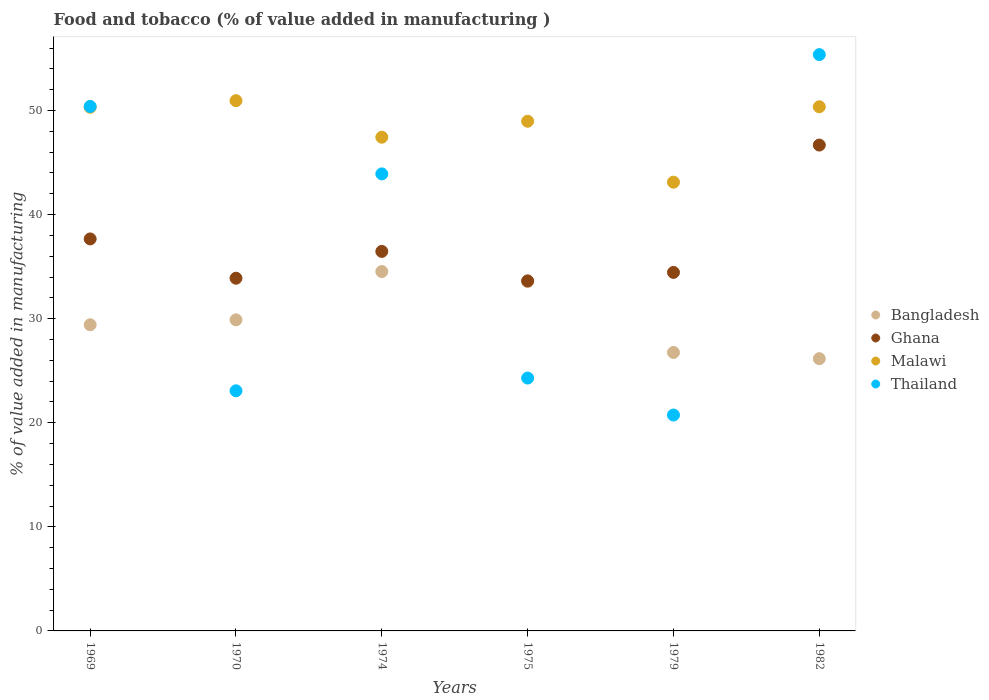How many different coloured dotlines are there?
Offer a very short reply. 4. Is the number of dotlines equal to the number of legend labels?
Ensure brevity in your answer.  Yes. What is the value added in manufacturing food and tobacco in Bangladesh in 1979?
Your answer should be very brief. 26.75. Across all years, what is the maximum value added in manufacturing food and tobacco in Ghana?
Your answer should be very brief. 46.68. Across all years, what is the minimum value added in manufacturing food and tobacco in Ghana?
Your answer should be compact. 33.63. In which year was the value added in manufacturing food and tobacco in Thailand maximum?
Make the answer very short. 1982. In which year was the value added in manufacturing food and tobacco in Malawi minimum?
Your answer should be very brief. 1979. What is the total value added in manufacturing food and tobacco in Thailand in the graph?
Keep it short and to the point. 217.79. What is the difference between the value added in manufacturing food and tobacco in Thailand in 1970 and that in 1974?
Your answer should be very brief. -20.84. What is the difference between the value added in manufacturing food and tobacco in Malawi in 1979 and the value added in manufacturing food and tobacco in Bangladesh in 1974?
Keep it short and to the point. 8.59. What is the average value added in manufacturing food and tobacco in Bangladesh per year?
Give a very brief answer. 30.05. In the year 1975, what is the difference between the value added in manufacturing food and tobacco in Bangladesh and value added in manufacturing food and tobacco in Thailand?
Make the answer very short. 9.27. In how many years, is the value added in manufacturing food and tobacco in Ghana greater than 20 %?
Make the answer very short. 6. What is the ratio of the value added in manufacturing food and tobacco in Bangladesh in 1974 to that in 1982?
Offer a terse response. 1.32. Is the value added in manufacturing food and tobacco in Thailand in 1979 less than that in 1982?
Provide a succinct answer. Yes. Is the difference between the value added in manufacturing food and tobacco in Bangladesh in 1979 and 1982 greater than the difference between the value added in manufacturing food and tobacco in Thailand in 1979 and 1982?
Your response must be concise. Yes. What is the difference between the highest and the second highest value added in manufacturing food and tobacco in Malawi?
Offer a very short reply. 0.58. What is the difference between the highest and the lowest value added in manufacturing food and tobacco in Ghana?
Your answer should be compact. 13.05. Is the sum of the value added in manufacturing food and tobacco in Malawi in 1975 and 1982 greater than the maximum value added in manufacturing food and tobacco in Thailand across all years?
Give a very brief answer. Yes. Is it the case that in every year, the sum of the value added in manufacturing food and tobacco in Thailand and value added in manufacturing food and tobacco in Malawi  is greater than the sum of value added in manufacturing food and tobacco in Ghana and value added in manufacturing food and tobacco in Bangladesh?
Offer a terse response. No. Is the value added in manufacturing food and tobacco in Bangladesh strictly greater than the value added in manufacturing food and tobacco in Thailand over the years?
Offer a terse response. No. Is the value added in manufacturing food and tobacco in Thailand strictly less than the value added in manufacturing food and tobacco in Ghana over the years?
Offer a terse response. No. How many dotlines are there?
Offer a terse response. 4. Does the graph contain grids?
Your response must be concise. No. How are the legend labels stacked?
Make the answer very short. Vertical. What is the title of the graph?
Offer a terse response. Food and tobacco (% of value added in manufacturing ). What is the label or title of the X-axis?
Provide a short and direct response. Years. What is the label or title of the Y-axis?
Your answer should be very brief. % of value added in manufacturing. What is the % of value added in manufacturing in Bangladesh in 1969?
Provide a short and direct response. 29.42. What is the % of value added in manufacturing of Ghana in 1969?
Your response must be concise. 37.66. What is the % of value added in manufacturing of Malawi in 1969?
Your answer should be very brief. 50.32. What is the % of value added in manufacturing of Thailand in 1969?
Your response must be concise. 50.39. What is the % of value added in manufacturing in Bangladesh in 1970?
Provide a short and direct response. 29.89. What is the % of value added in manufacturing of Ghana in 1970?
Make the answer very short. 33.89. What is the % of value added in manufacturing in Malawi in 1970?
Keep it short and to the point. 50.95. What is the % of value added in manufacturing in Thailand in 1970?
Your answer should be compact. 23.07. What is the % of value added in manufacturing in Bangladesh in 1974?
Make the answer very short. 34.53. What is the % of value added in manufacturing in Ghana in 1974?
Ensure brevity in your answer.  36.46. What is the % of value added in manufacturing of Malawi in 1974?
Give a very brief answer. 47.44. What is the % of value added in manufacturing in Thailand in 1974?
Offer a very short reply. 43.91. What is the % of value added in manufacturing in Bangladesh in 1975?
Offer a terse response. 33.56. What is the % of value added in manufacturing of Ghana in 1975?
Offer a terse response. 33.63. What is the % of value added in manufacturing of Malawi in 1975?
Provide a short and direct response. 48.97. What is the % of value added in manufacturing of Thailand in 1975?
Ensure brevity in your answer.  24.3. What is the % of value added in manufacturing in Bangladesh in 1979?
Make the answer very short. 26.75. What is the % of value added in manufacturing in Ghana in 1979?
Offer a terse response. 34.45. What is the % of value added in manufacturing in Malawi in 1979?
Offer a terse response. 43.12. What is the % of value added in manufacturing in Thailand in 1979?
Give a very brief answer. 20.74. What is the % of value added in manufacturing of Bangladesh in 1982?
Give a very brief answer. 26.16. What is the % of value added in manufacturing of Ghana in 1982?
Provide a short and direct response. 46.68. What is the % of value added in manufacturing of Malawi in 1982?
Provide a short and direct response. 50.36. What is the % of value added in manufacturing of Thailand in 1982?
Offer a very short reply. 55.37. Across all years, what is the maximum % of value added in manufacturing of Bangladesh?
Make the answer very short. 34.53. Across all years, what is the maximum % of value added in manufacturing in Ghana?
Make the answer very short. 46.68. Across all years, what is the maximum % of value added in manufacturing in Malawi?
Ensure brevity in your answer.  50.95. Across all years, what is the maximum % of value added in manufacturing in Thailand?
Make the answer very short. 55.37. Across all years, what is the minimum % of value added in manufacturing in Bangladesh?
Your answer should be very brief. 26.16. Across all years, what is the minimum % of value added in manufacturing in Ghana?
Keep it short and to the point. 33.63. Across all years, what is the minimum % of value added in manufacturing in Malawi?
Offer a terse response. 43.12. Across all years, what is the minimum % of value added in manufacturing in Thailand?
Make the answer very short. 20.74. What is the total % of value added in manufacturing in Bangladesh in the graph?
Give a very brief answer. 180.31. What is the total % of value added in manufacturing of Ghana in the graph?
Keep it short and to the point. 222.78. What is the total % of value added in manufacturing of Malawi in the graph?
Ensure brevity in your answer.  291.15. What is the total % of value added in manufacturing of Thailand in the graph?
Offer a very short reply. 217.79. What is the difference between the % of value added in manufacturing in Bangladesh in 1969 and that in 1970?
Your answer should be very brief. -0.47. What is the difference between the % of value added in manufacturing in Ghana in 1969 and that in 1970?
Your answer should be very brief. 3.77. What is the difference between the % of value added in manufacturing of Malawi in 1969 and that in 1970?
Your answer should be very brief. -0.63. What is the difference between the % of value added in manufacturing in Thailand in 1969 and that in 1970?
Provide a short and direct response. 27.32. What is the difference between the % of value added in manufacturing in Bangladesh in 1969 and that in 1974?
Your response must be concise. -5.11. What is the difference between the % of value added in manufacturing of Ghana in 1969 and that in 1974?
Your answer should be very brief. 1.2. What is the difference between the % of value added in manufacturing of Malawi in 1969 and that in 1974?
Provide a succinct answer. 2.88. What is the difference between the % of value added in manufacturing of Thailand in 1969 and that in 1974?
Offer a terse response. 6.48. What is the difference between the % of value added in manufacturing in Bangladesh in 1969 and that in 1975?
Give a very brief answer. -4.15. What is the difference between the % of value added in manufacturing in Ghana in 1969 and that in 1975?
Offer a very short reply. 4.03. What is the difference between the % of value added in manufacturing in Malawi in 1969 and that in 1975?
Provide a succinct answer. 1.35. What is the difference between the % of value added in manufacturing of Thailand in 1969 and that in 1975?
Provide a short and direct response. 26.1. What is the difference between the % of value added in manufacturing in Bangladesh in 1969 and that in 1979?
Make the answer very short. 2.66. What is the difference between the % of value added in manufacturing of Ghana in 1969 and that in 1979?
Keep it short and to the point. 3.22. What is the difference between the % of value added in manufacturing in Malawi in 1969 and that in 1979?
Offer a very short reply. 7.2. What is the difference between the % of value added in manufacturing of Thailand in 1969 and that in 1979?
Ensure brevity in your answer.  29.65. What is the difference between the % of value added in manufacturing in Bangladesh in 1969 and that in 1982?
Make the answer very short. 3.26. What is the difference between the % of value added in manufacturing in Ghana in 1969 and that in 1982?
Ensure brevity in your answer.  -9.02. What is the difference between the % of value added in manufacturing in Malawi in 1969 and that in 1982?
Provide a short and direct response. -0.05. What is the difference between the % of value added in manufacturing of Thailand in 1969 and that in 1982?
Your response must be concise. -4.98. What is the difference between the % of value added in manufacturing of Bangladesh in 1970 and that in 1974?
Make the answer very short. -4.64. What is the difference between the % of value added in manufacturing of Ghana in 1970 and that in 1974?
Your answer should be compact. -2.58. What is the difference between the % of value added in manufacturing in Malawi in 1970 and that in 1974?
Provide a short and direct response. 3.51. What is the difference between the % of value added in manufacturing of Thailand in 1970 and that in 1974?
Offer a terse response. -20.84. What is the difference between the % of value added in manufacturing in Bangladesh in 1970 and that in 1975?
Provide a short and direct response. -3.67. What is the difference between the % of value added in manufacturing of Ghana in 1970 and that in 1975?
Give a very brief answer. 0.26. What is the difference between the % of value added in manufacturing of Malawi in 1970 and that in 1975?
Give a very brief answer. 1.98. What is the difference between the % of value added in manufacturing of Thailand in 1970 and that in 1975?
Ensure brevity in your answer.  -1.23. What is the difference between the % of value added in manufacturing of Bangladesh in 1970 and that in 1979?
Provide a succinct answer. 3.14. What is the difference between the % of value added in manufacturing of Ghana in 1970 and that in 1979?
Ensure brevity in your answer.  -0.56. What is the difference between the % of value added in manufacturing of Malawi in 1970 and that in 1979?
Provide a short and direct response. 7.83. What is the difference between the % of value added in manufacturing of Thailand in 1970 and that in 1979?
Offer a very short reply. 2.33. What is the difference between the % of value added in manufacturing in Bangladesh in 1970 and that in 1982?
Provide a short and direct response. 3.73. What is the difference between the % of value added in manufacturing of Ghana in 1970 and that in 1982?
Keep it short and to the point. -12.79. What is the difference between the % of value added in manufacturing of Malawi in 1970 and that in 1982?
Make the answer very short. 0.58. What is the difference between the % of value added in manufacturing of Thailand in 1970 and that in 1982?
Your answer should be very brief. -32.3. What is the difference between the % of value added in manufacturing in Bangladesh in 1974 and that in 1975?
Your answer should be very brief. 0.97. What is the difference between the % of value added in manufacturing of Ghana in 1974 and that in 1975?
Make the answer very short. 2.83. What is the difference between the % of value added in manufacturing in Malawi in 1974 and that in 1975?
Your response must be concise. -1.53. What is the difference between the % of value added in manufacturing in Thailand in 1974 and that in 1975?
Keep it short and to the point. 19.62. What is the difference between the % of value added in manufacturing of Bangladesh in 1974 and that in 1979?
Your response must be concise. 7.78. What is the difference between the % of value added in manufacturing in Ghana in 1974 and that in 1979?
Provide a succinct answer. 2.02. What is the difference between the % of value added in manufacturing in Malawi in 1974 and that in 1979?
Ensure brevity in your answer.  4.32. What is the difference between the % of value added in manufacturing of Thailand in 1974 and that in 1979?
Offer a very short reply. 23.17. What is the difference between the % of value added in manufacturing of Bangladesh in 1974 and that in 1982?
Your answer should be very brief. 8.37. What is the difference between the % of value added in manufacturing of Ghana in 1974 and that in 1982?
Make the answer very short. -10.22. What is the difference between the % of value added in manufacturing in Malawi in 1974 and that in 1982?
Make the answer very short. -2.93. What is the difference between the % of value added in manufacturing of Thailand in 1974 and that in 1982?
Give a very brief answer. -11.46. What is the difference between the % of value added in manufacturing in Bangladesh in 1975 and that in 1979?
Your response must be concise. 6.81. What is the difference between the % of value added in manufacturing in Ghana in 1975 and that in 1979?
Your answer should be very brief. -0.81. What is the difference between the % of value added in manufacturing of Malawi in 1975 and that in 1979?
Your answer should be compact. 5.86. What is the difference between the % of value added in manufacturing in Thailand in 1975 and that in 1979?
Your response must be concise. 3.55. What is the difference between the % of value added in manufacturing of Bangladesh in 1975 and that in 1982?
Ensure brevity in your answer.  7.41. What is the difference between the % of value added in manufacturing in Ghana in 1975 and that in 1982?
Offer a terse response. -13.05. What is the difference between the % of value added in manufacturing of Malawi in 1975 and that in 1982?
Provide a short and direct response. -1.39. What is the difference between the % of value added in manufacturing in Thailand in 1975 and that in 1982?
Ensure brevity in your answer.  -31.08. What is the difference between the % of value added in manufacturing of Bangladesh in 1979 and that in 1982?
Offer a very short reply. 0.6. What is the difference between the % of value added in manufacturing of Ghana in 1979 and that in 1982?
Your answer should be compact. -12.24. What is the difference between the % of value added in manufacturing of Malawi in 1979 and that in 1982?
Your answer should be very brief. -7.25. What is the difference between the % of value added in manufacturing of Thailand in 1979 and that in 1982?
Make the answer very short. -34.63. What is the difference between the % of value added in manufacturing of Bangladesh in 1969 and the % of value added in manufacturing of Ghana in 1970?
Your response must be concise. -4.47. What is the difference between the % of value added in manufacturing in Bangladesh in 1969 and the % of value added in manufacturing in Malawi in 1970?
Offer a terse response. -21.53. What is the difference between the % of value added in manufacturing of Bangladesh in 1969 and the % of value added in manufacturing of Thailand in 1970?
Make the answer very short. 6.35. What is the difference between the % of value added in manufacturing of Ghana in 1969 and the % of value added in manufacturing of Malawi in 1970?
Offer a very short reply. -13.28. What is the difference between the % of value added in manufacturing of Ghana in 1969 and the % of value added in manufacturing of Thailand in 1970?
Offer a very short reply. 14.59. What is the difference between the % of value added in manufacturing in Malawi in 1969 and the % of value added in manufacturing in Thailand in 1970?
Provide a succinct answer. 27.25. What is the difference between the % of value added in manufacturing of Bangladesh in 1969 and the % of value added in manufacturing of Ghana in 1974?
Offer a very short reply. -7.05. What is the difference between the % of value added in manufacturing in Bangladesh in 1969 and the % of value added in manufacturing in Malawi in 1974?
Give a very brief answer. -18.02. What is the difference between the % of value added in manufacturing in Bangladesh in 1969 and the % of value added in manufacturing in Thailand in 1974?
Offer a very short reply. -14.49. What is the difference between the % of value added in manufacturing of Ghana in 1969 and the % of value added in manufacturing of Malawi in 1974?
Your answer should be compact. -9.77. What is the difference between the % of value added in manufacturing of Ghana in 1969 and the % of value added in manufacturing of Thailand in 1974?
Your answer should be compact. -6.25. What is the difference between the % of value added in manufacturing in Malawi in 1969 and the % of value added in manufacturing in Thailand in 1974?
Make the answer very short. 6.4. What is the difference between the % of value added in manufacturing of Bangladesh in 1969 and the % of value added in manufacturing of Ghana in 1975?
Give a very brief answer. -4.22. What is the difference between the % of value added in manufacturing in Bangladesh in 1969 and the % of value added in manufacturing in Malawi in 1975?
Your answer should be compact. -19.55. What is the difference between the % of value added in manufacturing in Bangladesh in 1969 and the % of value added in manufacturing in Thailand in 1975?
Your response must be concise. 5.12. What is the difference between the % of value added in manufacturing in Ghana in 1969 and the % of value added in manufacturing in Malawi in 1975?
Provide a short and direct response. -11.31. What is the difference between the % of value added in manufacturing in Ghana in 1969 and the % of value added in manufacturing in Thailand in 1975?
Provide a succinct answer. 13.37. What is the difference between the % of value added in manufacturing in Malawi in 1969 and the % of value added in manufacturing in Thailand in 1975?
Your response must be concise. 26.02. What is the difference between the % of value added in manufacturing of Bangladesh in 1969 and the % of value added in manufacturing of Ghana in 1979?
Provide a short and direct response. -5.03. What is the difference between the % of value added in manufacturing in Bangladesh in 1969 and the % of value added in manufacturing in Malawi in 1979?
Your answer should be very brief. -13.7. What is the difference between the % of value added in manufacturing of Bangladesh in 1969 and the % of value added in manufacturing of Thailand in 1979?
Your answer should be very brief. 8.67. What is the difference between the % of value added in manufacturing in Ghana in 1969 and the % of value added in manufacturing in Malawi in 1979?
Provide a short and direct response. -5.45. What is the difference between the % of value added in manufacturing in Ghana in 1969 and the % of value added in manufacturing in Thailand in 1979?
Make the answer very short. 16.92. What is the difference between the % of value added in manufacturing of Malawi in 1969 and the % of value added in manufacturing of Thailand in 1979?
Keep it short and to the point. 29.57. What is the difference between the % of value added in manufacturing in Bangladesh in 1969 and the % of value added in manufacturing in Ghana in 1982?
Offer a very short reply. -17.27. What is the difference between the % of value added in manufacturing of Bangladesh in 1969 and the % of value added in manufacturing of Malawi in 1982?
Provide a succinct answer. -20.95. What is the difference between the % of value added in manufacturing in Bangladesh in 1969 and the % of value added in manufacturing in Thailand in 1982?
Give a very brief answer. -25.96. What is the difference between the % of value added in manufacturing in Ghana in 1969 and the % of value added in manufacturing in Malawi in 1982?
Provide a short and direct response. -12.7. What is the difference between the % of value added in manufacturing of Ghana in 1969 and the % of value added in manufacturing of Thailand in 1982?
Your answer should be compact. -17.71. What is the difference between the % of value added in manufacturing in Malawi in 1969 and the % of value added in manufacturing in Thailand in 1982?
Your answer should be very brief. -5.06. What is the difference between the % of value added in manufacturing in Bangladesh in 1970 and the % of value added in manufacturing in Ghana in 1974?
Your answer should be compact. -6.57. What is the difference between the % of value added in manufacturing of Bangladesh in 1970 and the % of value added in manufacturing of Malawi in 1974?
Offer a very short reply. -17.54. What is the difference between the % of value added in manufacturing in Bangladesh in 1970 and the % of value added in manufacturing in Thailand in 1974?
Your answer should be compact. -14.02. What is the difference between the % of value added in manufacturing in Ghana in 1970 and the % of value added in manufacturing in Malawi in 1974?
Ensure brevity in your answer.  -13.55. What is the difference between the % of value added in manufacturing of Ghana in 1970 and the % of value added in manufacturing of Thailand in 1974?
Provide a succinct answer. -10.02. What is the difference between the % of value added in manufacturing of Malawi in 1970 and the % of value added in manufacturing of Thailand in 1974?
Give a very brief answer. 7.04. What is the difference between the % of value added in manufacturing of Bangladesh in 1970 and the % of value added in manufacturing of Ghana in 1975?
Your answer should be very brief. -3.74. What is the difference between the % of value added in manufacturing of Bangladesh in 1970 and the % of value added in manufacturing of Malawi in 1975?
Provide a short and direct response. -19.08. What is the difference between the % of value added in manufacturing of Bangladesh in 1970 and the % of value added in manufacturing of Thailand in 1975?
Your response must be concise. 5.6. What is the difference between the % of value added in manufacturing of Ghana in 1970 and the % of value added in manufacturing of Malawi in 1975?
Your answer should be compact. -15.08. What is the difference between the % of value added in manufacturing in Ghana in 1970 and the % of value added in manufacturing in Thailand in 1975?
Your answer should be very brief. 9.59. What is the difference between the % of value added in manufacturing of Malawi in 1970 and the % of value added in manufacturing of Thailand in 1975?
Ensure brevity in your answer.  26.65. What is the difference between the % of value added in manufacturing in Bangladesh in 1970 and the % of value added in manufacturing in Ghana in 1979?
Offer a terse response. -4.56. What is the difference between the % of value added in manufacturing of Bangladesh in 1970 and the % of value added in manufacturing of Malawi in 1979?
Keep it short and to the point. -13.22. What is the difference between the % of value added in manufacturing in Bangladesh in 1970 and the % of value added in manufacturing in Thailand in 1979?
Your answer should be very brief. 9.15. What is the difference between the % of value added in manufacturing of Ghana in 1970 and the % of value added in manufacturing of Malawi in 1979?
Offer a terse response. -9.23. What is the difference between the % of value added in manufacturing in Ghana in 1970 and the % of value added in manufacturing in Thailand in 1979?
Give a very brief answer. 13.14. What is the difference between the % of value added in manufacturing in Malawi in 1970 and the % of value added in manufacturing in Thailand in 1979?
Provide a succinct answer. 30.2. What is the difference between the % of value added in manufacturing of Bangladesh in 1970 and the % of value added in manufacturing of Ghana in 1982?
Provide a succinct answer. -16.79. What is the difference between the % of value added in manufacturing in Bangladesh in 1970 and the % of value added in manufacturing in Malawi in 1982?
Ensure brevity in your answer.  -20.47. What is the difference between the % of value added in manufacturing of Bangladesh in 1970 and the % of value added in manufacturing of Thailand in 1982?
Your answer should be very brief. -25.48. What is the difference between the % of value added in manufacturing of Ghana in 1970 and the % of value added in manufacturing of Malawi in 1982?
Offer a very short reply. -16.47. What is the difference between the % of value added in manufacturing in Ghana in 1970 and the % of value added in manufacturing in Thailand in 1982?
Your response must be concise. -21.49. What is the difference between the % of value added in manufacturing in Malawi in 1970 and the % of value added in manufacturing in Thailand in 1982?
Provide a short and direct response. -4.43. What is the difference between the % of value added in manufacturing of Bangladesh in 1974 and the % of value added in manufacturing of Ghana in 1975?
Provide a short and direct response. 0.9. What is the difference between the % of value added in manufacturing of Bangladesh in 1974 and the % of value added in manufacturing of Malawi in 1975?
Keep it short and to the point. -14.44. What is the difference between the % of value added in manufacturing in Bangladesh in 1974 and the % of value added in manufacturing in Thailand in 1975?
Your answer should be compact. 10.23. What is the difference between the % of value added in manufacturing in Ghana in 1974 and the % of value added in manufacturing in Malawi in 1975?
Your answer should be very brief. -12.51. What is the difference between the % of value added in manufacturing in Ghana in 1974 and the % of value added in manufacturing in Thailand in 1975?
Your response must be concise. 12.17. What is the difference between the % of value added in manufacturing of Malawi in 1974 and the % of value added in manufacturing of Thailand in 1975?
Ensure brevity in your answer.  23.14. What is the difference between the % of value added in manufacturing of Bangladesh in 1974 and the % of value added in manufacturing of Ghana in 1979?
Your answer should be very brief. 0.08. What is the difference between the % of value added in manufacturing in Bangladesh in 1974 and the % of value added in manufacturing in Malawi in 1979?
Offer a terse response. -8.59. What is the difference between the % of value added in manufacturing of Bangladesh in 1974 and the % of value added in manufacturing of Thailand in 1979?
Your answer should be compact. 13.79. What is the difference between the % of value added in manufacturing of Ghana in 1974 and the % of value added in manufacturing of Malawi in 1979?
Offer a very short reply. -6.65. What is the difference between the % of value added in manufacturing of Ghana in 1974 and the % of value added in manufacturing of Thailand in 1979?
Ensure brevity in your answer.  15.72. What is the difference between the % of value added in manufacturing in Malawi in 1974 and the % of value added in manufacturing in Thailand in 1979?
Your answer should be very brief. 26.69. What is the difference between the % of value added in manufacturing in Bangladesh in 1974 and the % of value added in manufacturing in Ghana in 1982?
Provide a short and direct response. -12.15. What is the difference between the % of value added in manufacturing of Bangladesh in 1974 and the % of value added in manufacturing of Malawi in 1982?
Provide a succinct answer. -15.83. What is the difference between the % of value added in manufacturing in Bangladesh in 1974 and the % of value added in manufacturing in Thailand in 1982?
Make the answer very short. -20.84. What is the difference between the % of value added in manufacturing in Ghana in 1974 and the % of value added in manufacturing in Malawi in 1982?
Provide a succinct answer. -13.9. What is the difference between the % of value added in manufacturing of Ghana in 1974 and the % of value added in manufacturing of Thailand in 1982?
Your answer should be compact. -18.91. What is the difference between the % of value added in manufacturing of Malawi in 1974 and the % of value added in manufacturing of Thailand in 1982?
Offer a terse response. -7.94. What is the difference between the % of value added in manufacturing in Bangladesh in 1975 and the % of value added in manufacturing in Ghana in 1979?
Offer a terse response. -0.88. What is the difference between the % of value added in manufacturing in Bangladesh in 1975 and the % of value added in manufacturing in Malawi in 1979?
Provide a succinct answer. -9.55. What is the difference between the % of value added in manufacturing in Bangladesh in 1975 and the % of value added in manufacturing in Thailand in 1979?
Provide a short and direct response. 12.82. What is the difference between the % of value added in manufacturing in Ghana in 1975 and the % of value added in manufacturing in Malawi in 1979?
Make the answer very short. -9.48. What is the difference between the % of value added in manufacturing in Ghana in 1975 and the % of value added in manufacturing in Thailand in 1979?
Your answer should be compact. 12.89. What is the difference between the % of value added in manufacturing of Malawi in 1975 and the % of value added in manufacturing of Thailand in 1979?
Provide a succinct answer. 28.23. What is the difference between the % of value added in manufacturing of Bangladesh in 1975 and the % of value added in manufacturing of Ghana in 1982?
Make the answer very short. -13.12. What is the difference between the % of value added in manufacturing of Bangladesh in 1975 and the % of value added in manufacturing of Malawi in 1982?
Provide a short and direct response. -16.8. What is the difference between the % of value added in manufacturing in Bangladesh in 1975 and the % of value added in manufacturing in Thailand in 1982?
Offer a very short reply. -21.81. What is the difference between the % of value added in manufacturing of Ghana in 1975 and the % of value added in manufacturing of Malawi in 1982?
Give a very brief answer. -16.73. What is the difference between the % of value added in manufacturing of Ghana in 1975 and the % of value added in manufacturing of Thailand in 1982?
Ensure brevity in your answer.  -21.74. What is the difference between the % of value added in manufacturing of Malawi in 1975 and the % of value added in manufacturing of Thailand in 1982?
Offer a very short reply. -6.4. What is the difference between the % of value added in manufacturing of Bangladesh in 1979 and the % of value added in manufacturing of Ghana in 1982?
Give a very brief answer. -19.93. What is the difference between the % of value added in manufacturing of Bangladesh in 1979 and the % of value added in manufacturing of Malawi in 1982?
Offer a very short reply. -23.61. What is the difference between the % of value added in manufacturing of Bangladesh in 1979 and the % of value added in manufacturing of Thailand in 1982?
Keep it short and to the point. -28.62. What is the difference between the % of value added in manufacturing of Ghana in 1979 and the % of value added in manufacturing of Malawi in 1982?
Provide a succinct answer. -15.92. What is the difference between the % of value added in manufacturing of Ghana in 1979 and the % of value added in manufacturing of Thailand in 1982?
Your response must be concise. -20.93. What is the difference between the % of value added in manufacturing in Malawi in 1979 and the % of value added in manufacturing in Thailand in 1982?
Ensure brevity in your answer.  -12.26. What is the average % of value added in manufacturing in Bangladesh per year?
Offer a terse response. 30.05. What is the average % of value added in manufacturing of Ghana per year?
Provide a short and direct response. 37.13. What is the average % of value added in manufacturing in Malawi per year?
Your response must be concise. 48.52. What is the average % of value added in manufacturing of Thailand per year?
Your response must be concise. 36.3. In the year 1969, what is the difference between the % of value added in manufacturing in Bangladesh and % of value added in manufacturing in Ghana?
Offer a very short reply. -8.25. In the year 1969, what is the difference between the % of value added in manufacturing in Bangladesh and % of value added in manufacturing in Malawi?
Provide a succinct answer. -20.9. In the year 1969, what is the difference between the % of value added in manufacturing of Bangladesh and % of value added in manufacturing of Thailand?
Your answer should be very brief. -20.98. In the year 1969, what is the difference between the % of value added in manufacturing in Ghana and % of value added in manufacturing in Malawi?
Provide a short and direct response. -12.65. In the year 1969, what is the difference between the % of value added in manufacturing in Ghana and % of value added in manufacturing in Thailand?
Your response must be concise. -12.73. In the year 1969, what is the difference between the % of value added in manufacturing in Malawi and % of value added in manufacturing in Thailand?
Your answer should be compact. -0.08. In the year 1970, what is the difference between the % of value added in manufacturing in Bangladesh and % of value added in manufacturing in Ghana?
Offer a very short reply. -4. In the year 1970, what is the difference between the % of value added in manufacturing in Bangladesh and % of value added in manufacturing in Malawi?
Ensure brevity in your answer.  -21.06. In the year 1970, what is the difference between the % of value added in manufacturing in Bangladesh and % of value added in manufacturing in Thailand?
Offer a terse response. 6.82. In the year 1970, what is the difference between the % of value added in manufacturing of Ghana and % of value added in manufacturing of Malawi?
Give a very brief answer. -17.06. In the year 1970, what is the difference between the % of value added in manufacturing of Ghana and % of value added in manufacturing of Thailand?
Offer a very short reply. 10.82. In the year 1970, what is the difference between the % of value added in manufacturing of Malawi and % of value added in manufacturing of Thailand?
Your answer should be compact. 27.88. In the year 1974, what is the difference between the % of value added in manufacturing of Bangladesh and % of value added in manufacturing of Ghana?
Offer a very short reply. -1.93. In the year 1974, what is the difference between the % of value added in manufacturing of Bangladesh and % of value added in manufacturing of Malawi?
Provide a succinct answer. -12.91. In the year 1974, what is the difference between the % of value added in manufacturing of Bangladesh and % of value added in manufacturing of Thailand?
Your response must be concise. -9.38. In the year 1974, what is the difference between the % of value added in manufacturing of Ghana and % of value added in manufacturing of Malawi?
Your response must be concise. -10.97. In the year 1974, what is the difference between the % of value added in manufacturing of Ghana and % of value added in manufacturing of Thailand?
Your answer should be very brief. -7.45. In the year 1974, what is the difference between the % of value added in manufacturing of Malawi and % of value added in manufacturing of Thailand?
Ensure brevity in your answer.  3.52. In the year 1975, what is the difference between the % of value added in manufacturing in Bangladesh and % of value added in manufacturing in Ghana?
Your answer should be very brief. -0.07. In the year 1975, what is the difference between the % of value added in manufacturing of Bangladesh and % of value added in manufacturing of Malawi?
Make the answer very short. -15.41. In the year 1975, what is the difference between the % of value added in manufacturing in Bangladesh and % of value added in manufacturing in Thailand?
Ensure brevity in your answer.  9.27. In the year 1975, what is the difference between the % of value added in manufacturing of Ghana and % of value added in manufacturing of Malawi?
Give a very brief answer. -15.34. In the year 1975, what is the difference between the % of value added in manufacturing of Ghana and % of value added in manufacturing of Thailand?
Give a very brief answer. 9.34. In the year 1975, what is the difference between the % of value added in manufacturing in Malawi and % of value added in manufacturing in Thailand?
Ensure brevity in your answer.  24.68. In the year 1979, what is the difference between the % of value added in manufacturing in Bangladesh and % of value added in manufacturing in Ghana?
Provide a short and direct response. -7.69. In the year 1979, what is the difference between the % of value added in manufacturing of Bangladesh and % of value added in manufacturing of Malawi?
Offer a terse response. -16.36. In the year 1979, what is the difference between the % of value added in manufacturing in Bangladesh and % of value added in manufacturing in Thailand?
Your answer should be compact. 6.01. In the year 1979, what is the difference between the % of value added in manufacturing in Ghana and % of value added in manufacturing in Malawi?
Keep it short and to the point. -8.67. In the year 1979, what is the difference between the % of value added in manufacturing of Ghana and % of value added in manufacturing of Thailand?
Provide a short and direct response. 13.7. In the year 1979, what is the difference between the % of value added in manufacturing in Malawi and % of value added in manufacturing in Thailand?
Your answer should be compact. 22.37. In the year 1982, what is the difference between the % of value added in manufacturing in Bangladesh and % of value added in manufacturing in Ghana?
Your answer should be compact. -20.52. In the year 1982, what is the difference between the % of value added in manufacturing of Bangladesh and % of value added in manufacturing of Malawi?
Keep it short and to the point. -24.2. In the year 1982, what is the difference between the % of value added in manufacturing of Bangladesh and % of value added in manufacturing of Thailand?
Your answer should be compact. -29.22. In the year 1982, what is the difference between the % of value added in manufacturing in Ghana and % of value added in manufacturing in Malawi?
Ensure brevity in your answer.  -3.68. In the year 1982, what is the difference between the % of value added in manufacturing of Ghana and % of value added in manufacturing of Thailand?
Your answer should be compact. -8.69. In the year 1982, what is the difference between the % of value added in manufacturing of Malawi and % of value added in manufacturing of Thailand?
Your response must be concise. -5.01. What is the ratio of the % of value added in manufacturing of Bangladesh in 1969 to that in 1970?
Make the answer very short. 0.98. What is the ratio of the % of value added in manufacturing in Ghana in 1969 to that in 1970?
Give a very brief answer. 1.11. What is the ratio of the % of value added in manufacturing of Malawi in 1969 to that in 1970?
Give a very brief answer. 0.99. What is the ratio of the % of value added in manufacturing in Thailand in 1969 to that in 1970?
Offer a very short reply. 2.18. What is the ratio of the % of value added in manufacturing of Bangladesh in 1969 to that in 1974?
Your answer should be very brief. 0.85. What is the ratio of the % of value added in manufacturing of Ghana in 1969 to that in 1974?
Provide a succinct answer. 1.03. What is the ratio of the % of value added in manufacturing of Malawi in 1969 to that in 1974?
Provide a succinct answer. 1.06. What is the ratio of the % of value added in manufacturing of Thailand in 1969 to that in 1974?
Ensure brevity in your answer.  1.15. What is the ratio of the % of value added in manufacturing of Bangladesh in 1969 to that in 1975?
Offer a very short reply. 0.88. What is the ratio of the % of value added in manufacturing in Ghana in 1969 to that in 1975?
Provide a short and direct response. 1.12. What is the ratio of the % of value added in manufacturing in Malawi in 1969 to that in 1975?
Ensure brevity in your answer.  1.03. What is the ratio of the % of value added in manufacturing of Thailand in 1969 to that in 1975?
Give a very brief answer. 2.07. What is the ratio of the % of value added in manufacturing of Bangladesh in 1969 to that in 1979?
Provide a succinct answer. 1.1. What is the ratio of the % of value added in manufacturing of Ghana in 1969 to that in 1979?
Give a very brief answer. 1.09. What is the ratio of the % of value added in manufacturing of Malawi in 1969 to that in 1979?
Offer a very short reply. 1.17. What is the ratio of the % of value added in manufacturing in Thailand in 1969 to that in 1979?
Provide a succinct answer. 2.43. What is the ratio of the % of value added in manufacturing of Bangladesh in 1969 to that in 1982?
Your answer should be compact. 1.12. What is the ratio of the % of value added in manufacturing of Ghana in 1969 to that in 1982?
Ensure brevity in your answer.  0.81. What is the ratio of the % of value added in manufacturing in Malawi in 1969 to that in 1982?
Your answer should be compact. 1. What is the ratio of the % of value added in manufacturing of Thailand in 1969 to that in 1982?
Ensure brevity in your answer.  0.91. What is the ratio of the % of value added in manufacturing in Bangladesh in 1970 to that in 1974?
Offer a terse response. 0.87. What is the ratio of the % of value added in manufacturing of Ghana in 1970 to that in 1974?
Keep it short and to the point. 0.93. What is the ratio of the % of value added in manufacturing of Malawi in 1970 to that in 1974?
Your answer should be very brief. 1.07. What is the ratio of the % of value added in manufacturing in Thailand in 1970 to that in 1974?
Offer a terse response. 0.53. What is the ratio of the % of value added in manufacturing of Bangladesh in 1970 to that in 1975?
Ensure brevity in your answer.  0.89. What is the ratio of the % of value added in manufacturing of Ghana in 1970 to that in 1975?
Give a very brief answer. 1.01. What is the ratio of the % of value added in manufacturing of Malawi in 1970 to that in 1975?
Your response must be concise. 1.04. What is the ratio of the % of value added in manufacturing of Thailand in 1970 to that in 1975?
Provide a short and direct response. 0.95. What is the ratio of the % of value added in manufacturing in Bangladesh in 1970 to that in 1979?
Your answer should be compact. 1.12. What is the ratio of the % of value added in manufacturing of Ghana in 1970 to that in 1979?
Your response must be concise. 0.98. What is the ratio of the % of value added in manufacturing of Malawi in 1970 to that in 1979?
Your response must be concise. 1.18. What is the ratio of the % of value added in manufacturing of Thailand in 1970 to that in 1979?
Your answer should be compact. 1.11. What is the ratio of the % of value added in manufacturing of Bangladesh in 1970 to that in 1982?
Offer a terse response. 1.14. What is the ratio of the % of value added in manufacturing in Ghana in 1970 to that in 1982?
Your answer should be very brief. 0.73. What is the ratio of the % of value added in manufacturing in Malawi in 1970 to that in 1982?
Keep it short and to the point. 1.01. What is the ratio of the % of value added in manufacturing in Thailand in 1970 to that in 1982?
Offer a terse response. 0.42. What is the ratio of the % of value added in manufacturing in Bangladesh in 1974 to that in 1975?
Your answer should be very brief. 1.03. What is the ratio of the % of value added in manufacturing in Ghana in 1974 to that in 1975?
Give a very brief answer. 1.08. What is the ratio of the % of value added in manufacturing of Malawi in 1974 to that in 1975?
Ensure brevity in your answer.  0.97. What is the ratio of the % of value added in manufacturing of Thailand in 1974 to that in 1975?
Keep it short and to the point. 1.81. What is the ratio of the % of value added in manufacturing of Bangladesh in 1974 to that in 1979?
Provide a short and direct response. 1.29. What is the ratio of the % of value added in manufacturing of Ghana in 1974 to that in 1979?
Keep it short and to the point. 1.06. What is the ratio of the % of value added in manufacturing of Malawi in 1974 to that in 1979?
Offer a terse response. 1.1. What is the ratio of the % of value added in manufacturing of Thailand in 1974 to that in 1979?
Keep it short and to the point. 2.12. What is the ratio of the % of value added in manufacturing in Bangladesh in 1974 to that in 1982?
Your answer should be compact. 1.32. What is the ratio of the % of value added in manufacturing of Ghana in 1974 to that in 1982?
Ensure brevity in your answer.  0.78. What is the ratio of the % of value added in manufacturing of Malawi in 1974 to that in 1982?
Provide a short and direct response. 0.94. What is the ratio of the % of value added in manufacturing of Thailand in 1974 to that in 1982?
Make the answer very short. 0.79. What is the ratio of the % of value added in manufacturing of Bangladesh in 1975 to that in 1979?
Your answer should be very brief. 1.25. What is the ratio of the % of value added in manufacturing in Ghana in 1975 to that in 1979?
Offer a very short reply. 0.98. What is the ratio of the % of value added in manufacturing in Malawi in 1975 to that in 1979?
Offer a terse response. 1.14. What is the ratio of the % of value added in manufacturing of Thailand in 1975 to that in 1979?
Make the answer very short. 1.17. What is the ratio of the % of value added in manufacturing in Bangladesh in 1975 to that in 1982?
Provide a short and direct response. 1.28. What is the ratio of the % of value added in manufacturing in Ghana in 1975 to that in 1982?
Your response must be concise. 0.72. What is the ratio of the % of value added in manufacturing in Malawi in 1975 to that in 1982?
Your answer should be compact. 0.97. What is the ratio of the % of value added in manufacturing of Thailand in 1975 to that in 1982?
Provide a short and direct response. 0.44. What is the ratio of the % of value added in manufacturing of Bangladesh in 1979 to that in 1982?
Make the answer very short. 1.02. What is the ratio of the % of value added in manufacturing of Ghana in 1979 to that in 1982?
Your answer should be very brief. 0.74. What is the ratio of the % of value added in manufacturing in Malawi in 1979 to that in 1982?
Offer a very short reply. 0.86. What is the ratio of the % of value added in manufacturing of Thailand in 1979 to that in 1982?
Your response must be concise. 0.37. What is the difference between the highest and the second highest % of value added in manufacturing in Bangladesh?
Offer a very short reply. 0.97. What is the difference between the highest and the second highest % of value added in manufacturing in Ghana?
Make the answer very short. 9.02. What is the difference between the highest and the second highest % of value added in manufacturing in Malawi?
Provide a succinct answer. 0.58. What is the difference between the highest and the second highest % of value added in manufacturing of Thailand?
Provide a succinct answer. 4.98. What is the difference between the highest and the lowest % of value added in manufacturing in Bangladesh?
Your response must be concise. 8.37. What is the difference between the highest and the lowest % of value added in manufacturing in Ghana?
Your response must be concise. 13.05. What is the difference between the highest and the lowest % of value added in manufacturing in Malawi?
Provide a short and direct response. 7.83. What is the difference between the highest and the lowest % of value added in manufacturing of Thailand?
Ensure brevity in your answer.  34.63. 